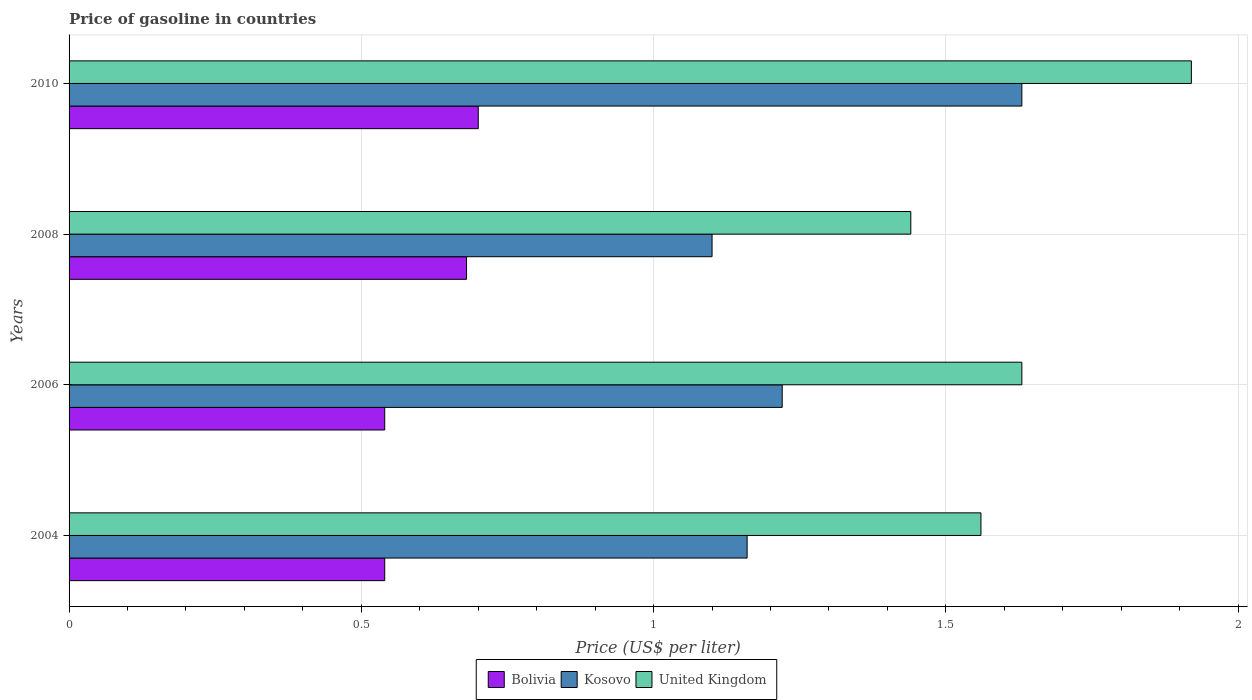How many different coloured bars are there?
Your response must be concise. 3. How many groups of bars are there?
Your response must be concise. 4. Are the number of bars per tick equal to the number of legend labels?
Your answer should be compact. Yes. Are the number of bars on each tick of the Y-axis equal?
Make the answer very short. Yes. How many bars are there on the 1st tick from the top?
Ensure brevity in your answer.  3. What is the label of the 1st group of bars from the top?
Make the answer very short. 2010. In how many cases, is the number of bars for a given year not equal to the number of legend labels?
Your answer should be very brief. 0. Across all years, what is the maximum price of gasoline in Bolivia?
Offer a very short reply. 0.7. Across all years, what is the minimum price of gasoline in United Kingdom?
Offer a very short reply. 1.44. In which year was the price of gasoline in Bolivia maximum?
Your response must be concise. 2010. In which year was the price of gasoline in United Kingdom minimum?
Offer a very short reply. 2008. What is the total price of gasoline in Kosovo in the graph?
Offer a very short reply. 5.11. What is the difference between the price of gasoline in Bolivia in 2008 and that in 2010?
Keep it short and to the point. -0.02. What is the difference between the price of gasoline in Bolivia in 2004 and the price of gasoline in Kosovo in 2010?
Give a very brief answer. -1.09. What is the average price of gasoline in United Kingdom per year?
Ensure brevity in your answer.  1.64. In the year 2008, what is the difference between the price of gasoline in Bolivia and price of gasoline in United Kingdom?
Offer a very short reply. -0.76. In how many years, is the price of gasoline in Bolivia greater than 0.30000000000000004 US$?
Offer a terse response. 4. What is the ratio of the price of gasoline in United Kingdom in 2004 to that in 2010?
Your response must be concise. 0.81. Is the price of gasoline in Kosovo in 2008 less than that in 2010?
Make the answer very short. Yes. What is the difference between the highest and the second highest price of gasoline in Kosovo?
Provide a succinct answer. 0.41. What is the difference between the highest and the lowest price of gasoline in Kosovo?
Your answer should be compact. 0.53. Is the sum of the price of gasoline in United Kingdom in 2006 and 2008 greater than the maximum price of gasoline in Kosovo across all years?
Provide a short and direct response. Yes. Is it the case that in every year, the sum of the price of gasoline in United Kingdom and price of gasoline in Kosovo is greater than the price of gasoline in Bolivia?
Provide a succinct answer. Yes. Are all the bars in the graph horizontal?
Your response must be concise. Yes. Where does the legend appear in the graph?
Provide a short and direct response. Bottom center. How many legend labels are there?
Your response must be concise. 3. How are the legend labels stacked?
Offer a terse response. Horizontal. What is the title of the graph?
Provide a succinct answer. Price of gasoline in countries. What is the label or title of the X-axis?
Offer a terse response. Price (US$ per liter). What is the Price (US$ per liter) in Bolivia in 2004?
Make the answer very short. 0.54. What is the Price (US$ per liter) in Kosovo in 2004?
Keep it short and to the point. 1.16. What is the Price (US$ per liter) of United Kingdom in 2004?
Your response must be concise. 1.56. What is the Price (US$ per liter) in Bolivia in 2006?
Ensure brevity in your answer.  0.54. What is the Price (US$ per liter) in Kosovo in 2006?
Make the answer very short. 1.22. What is the Price (US$ per liter) of United Kingdom in 2006?
Offer a very short reply. 1.63. What is the Price (US$ per liter) in Bolivia in 2008?
Your answer should be compact. 0.68. What is the Price (US$ per liter) in United Kingdom in 2008?
Make the answer very short. 1.44. What is the Price (US$ per liter) in Kosovo in 2010?
Your answer should be compact. 1.63. What is the Price (US$ per liter) in United Kingdom in 2010?
Provide a short and direct response. 1.92. Across all years, what is the maximum Price (US$ per liter) of Kosovo?
Your answer should be very brief. 1.63. Across all years, what is the maximum Price (US$ per liter) in United Kingdom?
Your answer should be compact. 1.92. Across all years, what is the minimum Price (US$ per liter) in Bolivia?
Give a very brief answer. 0.54. Across all years, what is the minimum Price (US$ per liter) in United Kingdom?
Your answer should be very brief. 1.44. What is the total Price (US$ per liter) in Bolivia in the graph?
Ensure brevity in your answer.  2.46. What is the total Price (US$ per liter) in Kosovo in the graph?
Your answer should be very brief. 5.11. What is the total Price (US$ per liter) of United Kingdom in the graph?
Your answer should be compact. 6.55. What is the difference between the Price (US$ per liter) of Bolivia in 2004 and that in 2006?
Provide a succinct answer. 0. What is the difference between the Price (US$ per liter) of Kosovo in 2004 and that in 2006?
Your answer should be very brief. -0.06. What is the difference between the Price (US$ per liter) of United Kingdom in 2004 and that in 2006?
Your answer should be compact. -0.07. What is the difference between the Price (US$ per liter) of Bolivia in 2004 and that in 2008?
Provide a short and direct response. -0.14. What is the difference between the Price (US$ per liter) of United Kingdom in 2004 and that in 2008?
Provide a succinct answer. 0.12. What is the difference between the Price (US$ per liter) in Bolivia in 2004 and that in 2010?
Your response must be concise. -0.16. What is the difference between the Price (US$ per liter) in Kosovo in 2004 and that in 2010?
Provide a succinct answer. -0.47. What is the difference between the Price (US$ per liter) in United Kingdom in 2004 and that in 2010?
Offer a very short reply. -0.36. What is the difference between the Price (US$ per liter) of Bolivia in 2006 and that in 2008?
Make the answer very short. -0.14. What is the difference between the Price (US$ per liter) in Kosovo in 2006 and that in 2008?
Offer a terse response. 0.12. What is the difference between the Price (US$ per liter) of United Kingdom in 2006 and that in 2008?
Provide a short and direct response. 0.19. What is the difference between the Price (US$ per liter) of Bolivia in 2006 and that in 2010?
Your response must be concise. -0.16. What is the difference between the Price (US$ per liter) of Kosovo in 2006 and that in 2010?
Provide a succinct answer. -0.41. What is the difference between the Price (US$ per liter) of United Kingdom in 2006 and that in 2010?
Keep it short and to the point. -0.29. What is the difference between the Price (US$ per liter) of Bolivia in 2008 and that in 2010?
Your response must be concise. -0.02. What is the difference between the Price (US$ per liter) of Kosovo in 2008 and that in 2010?
Provide a short and direct response. -0.53. What is the difference between the Price (US$ per liter) in United Kingdom in 2008 and that in 2010?
Offer a very short reply. -0.48. What is the difference between the Price (US$ per liter) in Bolivia in 2004 and the Price (US$ per liter) in Kosovo in 2006?
Make the answer very short. -0.68. What is the difference between the Price (US$ per liter) of Bolivia in 2004 and the Price (US$ per liter) of United Kingdom in 2006?
Keep it short and to the point. -1.09. What is the difference between the Price (US$ per liter) in Kosovo in 2004 and the Price (US$ per liter) in United Kingdom in 2006?
Make the answer very short. -0.47. What is the difference between the Price (US$ per liter) in Bolivia in 2004 and the Price (US$ per liter) in Kosovo in 2008?
Make the answer very short. -0.56. What is the difference between the Price (US$ per liter) of Kosovo in 2004 and the Price (US$ per liter) of United Kingdom in 2008?
Your answer should be very brief. -0.28. What is the difference between the Price (US$ per liter) of Bolivia in 2004 and the Price (US$ per liter) of Kosovo in 2010?
Offer a terse response. -1.09. What is the difference between the Price (US$ per liter) of Bolivia in 2004 and the Price (US$ per liter) of United Kingdom in 2010?
Offer a very short reply. -1.38. What is the difference between the Price (US$ per liter) in Kosovo in 2004 and the Price (US$ per liter) in United Kingdom in 2010?
Your response must be concise. -0.76. What is the difference between the Price (US$ per liter) of Bolivia in 2006 and the Price (US$ per liter) of Kosovo in 2008?
Your answer should be very brief. -0.56. What is the difference between the Price (US$ per liter) of Bolivia in 2006 and the Price (US$ per liter) of United Kingdom in 2008?
Make the answer very short. -0.9. What is the difference between the Price (US$ per liter) in Kosovo in 2006 and the Price (US$ per liter) in United Kingdom in 2008?
Your answer should be compact. -0.22. What is the difference between the Price (US$ per liter) in Bolivia in 2006 and the Price (US$ per liter) in Kosovo in 2010?
Your answer should be compact. -1.09. What is the difference between the Price (US$ per liter) of Bolivia in 2006 and the Price (US$ per liter) of United Kingdom in 2010?
Ensure brevity in your answer.  -1.38. What is the difference between the Price (US$ per liter) in Kosovo in 2006 and the Price (US$ per liter) in United Kingdom in 2010?
Give a very brief answer. -0.7. What is the difference between the Price (US$ per liter) of Bolivia in 2008 and the Price (US$ per liter) of Kosovo in 2010?
Provide a short and direct response. -0.95. What is the difference between the Price (US$ per liter) of Bolivia in 2008 and the Price (US$ per liter) of United Kingdom in 2010?
Your response must be concise. -1.24. What is the difference between the Price (US$ per liter) of Kosovo in 2008 and the Price (US$ per liter) of United Kingdom in 2010?
Ensure brevity in your answer.  -0.82. What is the average Price (US$ per liter) in Bolivia per year?
Make the answer very short. 0.61. What is the average Price (US$ per liter) of Kosovo per year?
Your response must be concise. 1.28. What is the average Price (US$ per liter) in United Kingdom per year?
Make the answer very short. 1.64. In the year 2004, what is the difference between the Price (US$ per liter) of Bolivia and Price (US$ per liter) of Kosovo?
Give a very brief answer. -0.62. In the year 2004, what is the difference between the Price (US$ per liter) of Bolivia and Price (US$ per liter) of United Kingdom?
Your answer should be compact. -1.02. In the year 2004, what is the difference between the Price (US$ per liter) in Kosovo and Price (US$ per liter) in United Kingdom?
Offer a terse response. -0.4. In the year 2006, what is the difference between the Price (US$ per liter) of Bolivia and Price (US$ per liter) of Kosovo?
Offer a terse response. -0.68. In the year 2006, what is the difference between the Price (US$ per liter) of Bolivia and Price (US$ per liter) of United Kingdom?
Your answer should be very brief. -1.09. In the year 2006, what is the difference between the Price (US$ per liter) of Kosovo and Price (US$ per liter) of United Kingdom?
Provide a short and direct response. -0.41. In the year 2008, what is the difference between the Price (US$ per liter) of Bolivia and Price (US$ per liter) of Kosovo?
Ensure brevity in your answer.  -0.42. In the year 2008, what is the difference between the Price (US$ per liter) in Bolivia and Price (US$ per liter) in United Kingdom?
Your response must be concise. -0.76. In the year 2008, what is the difference between the Price (US$ per liter) in Kosovo and Price (US$ per liter) in United Kingdom?
Give a very brief answer. -0.34. In the year 2010, what is the difference between the Price (US$ per liter) of Bolivia and Price (US$ per liter) of Kosovo?
Ensure brevity in your answer.  -0.93. In the year 2010, what is the difference between the Price (US$ per liter) of Bolivia and Price (US$ per liter) of United Kingdom?
Your answer should be compact. -1.22. In the year 2010, what is the difference between the Price (US$ per liter) in Kosovo and Price (US$ per liter) in United Kingdom?
Offer a terse response. -0.29. What is the ratio of the Price (US$ per liter) of Kosovo in 2004 to that in 2006?
Your response must be concise. 0.95. What is the ratio of the Price (US$ per liter) in United Kingdom in 2004 to that in 2006?
Keep it short and to the point. 0.96. What is the ratio of the Price (US$ per liter) in Bolivia in 2004 to that in 2008?
Keep it short and to the point. 0.79. What is the ratio of the Price (US$ per liter) of Kosovo in 2004 to that in 2008?
Ensure brevity in your answer.  1.05. What is the ratio of the Price (US$ per liter) in Bolivia in 2004 to that in 2010?
Offer a terse response. 0.77. What is the ratio of the Price (US$ per liter) in Kosovo in 2004 to that in 2010?
Your answer should be compact. 0.71. What is the ratio of the Price (US$ per liter) of United Kingdom in 2004 to that in 2010?
Keep it short and to the point. 0.81. What is the ratio of the Price (US$ per liter) in Bolivia in 2006 to that in 2008?
Provide a succinct answer. 0.79. What is the ratio of the Price (US$ per liter) in Kosovo in 2006 to that in 2008?
Your answer should be compact. 1.11. What is the ratio of the Price (US$ per liter) in United Kingdom in 2006 to that in 2008?
Keep it short and to the point. 1.13. What is the ratio of the Price (US$ per liter) in Bolivia in 2006 to that in 2010?
Your answer should be very brief. 0.77. What is the ratio of the Price (US$ per liter) in Kosovo in 2006 to that in 2010?
Offer a terse response. 0.75. What is the ratio of the Price (US$ per liter) in United Kingdom in 2006 to that in 2010?
Give a very brief answer. 0.85. What is the ratio of the Price (US$ per liter) of Bolivia in 2008 to that in 2010?
Provide a succinct answer. 0.97. What is the ratio of the Price (US$ per liter) in Kosovo in 2008 to that in 2010?
Provide a succinct answer. 0.67. What is the ratio of the Price (US$ per liter) in United Kingdom in 2008 to that in 2010?
Provide a short and direct response. 0.75. What is the difference between the highest and the second highest Price (US$ per liter) in Bolivia?
Give a very brief answer. 0.02. What is the difference between the highest and the second highest Price (US$ per liter) in Kosovo?
Your response must be concise. 0.41. What is the difference between the highest and the second highest Price (US$ per liter) in United Kingdom?
Offer a very short reply. 0.29. What is the difference between the highest and the lowest Price (US$ per liter) in Bolivia?
Offer a very short reply. 0.16. What is the difference between the highest and the lowest Price (US$ per liter) in Kosovo?
Provide a succinct answer. 0.53. What is the difference between the highest and the lowest Price (US$ per liter) of United Kingdom?
Offer a very short reply. 0.48. 